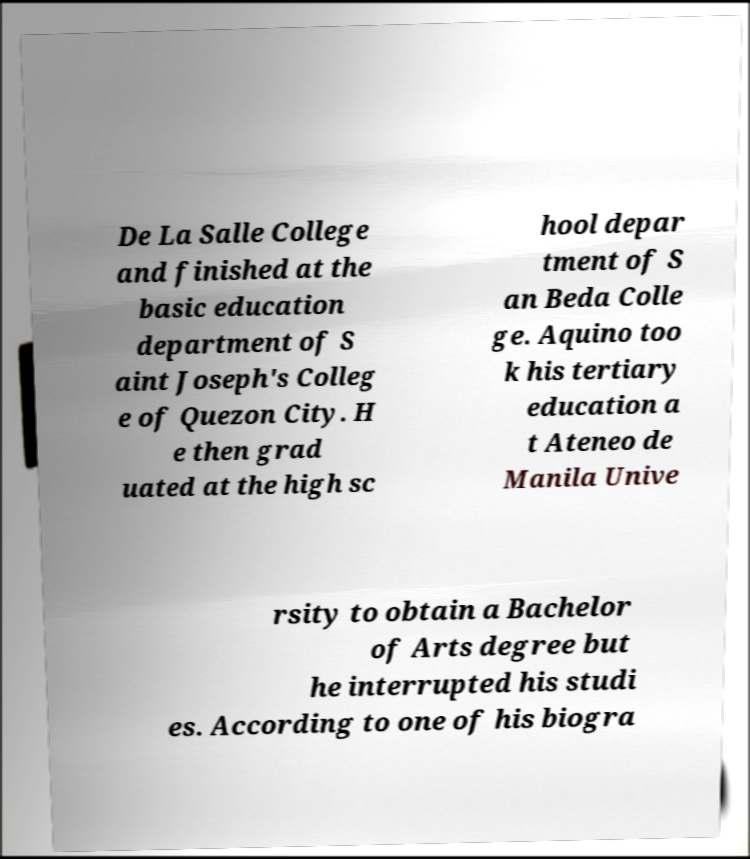What messages or text are displayed in this image? I need them in a readable, typed format. De La Salle College and finished at the basic education department of S aint Joseph's Colleg e of Quezon City. H e then grad uated at the high sc hool depar tment of S an Beda Colle ge. Aquino too k his tertiary education a t Ateneo de Manila Unive rsity to obtain a Bachelor of Arts degree but he interrupted his studi es. According to one of his biogra 